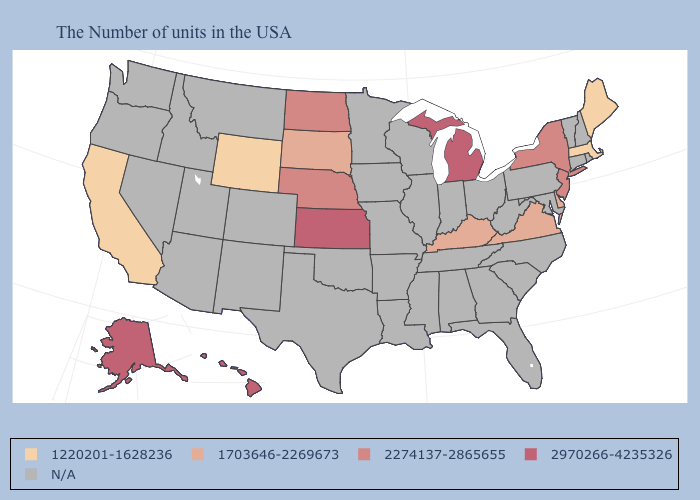What is the value of Kentucky?
Short answer required. 1703646-2269673. Which states have the lowest value in the MidWest?
Give a very brief answer. South Dakota. What is the value of Maine?
Keep it brief. 1220201-1628236. Does New Jersey have the lowest value in the USA?
Be succinct. No. Name the states that have a value in the range 2274137-2865655?
Concise answer only. New York, New Jersey, Nebraska, North Dakota. Does the first symbol in the legend represent the smallest category?
Quick response, please. Yes. What is the value of Rhode Island?
Give a very brief answer. N/A. What is the value of Idaho?
Short answer required. N/A. Among the states that border New York , does Massachusetts have the highest value?
Be succinct. No. Name the states that have a value in the range 1220201-1628236?
Short answer required. Maine, Massachusetts, Wyoming, California. Name the states that have a value in the range 1220201-1628236?
Short answer required. Maine, Massachusetts, Wyoming, California. What is the value of New Hampshire?
Short answer required. N/A. Does Nebraska have the highest value in the USA?
Give a very brief answer. No. What is the lowest value in the USA?
Concise answer only. 1220201-1628236. 